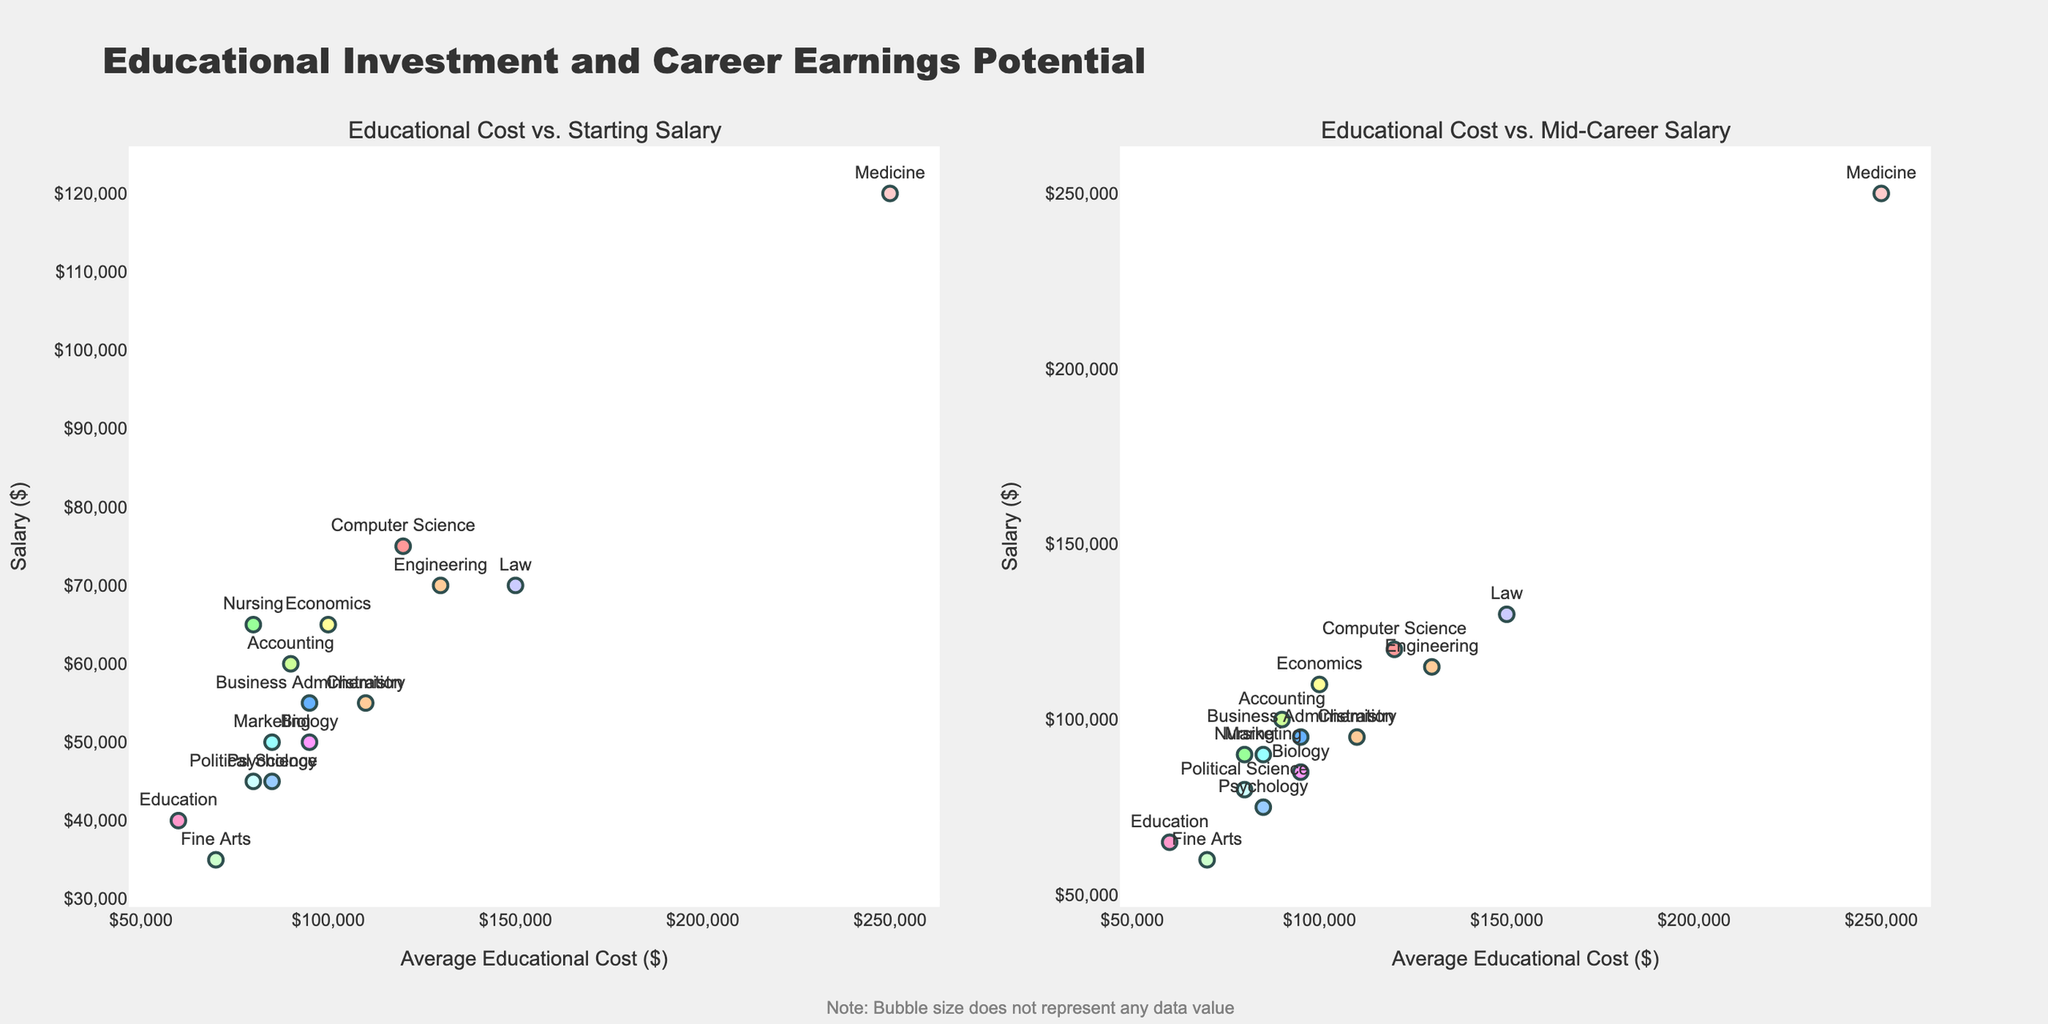How many intersections are represented in the figure? Count the number of unique intersections listed in the figure. Each intersection is represented as a data point with a label.
Answer: 10 Which intersection has the highest average wait time? Look at the y-axis in the first subplot and identify the data point with the highest value. The label for this data point indicates the intersection.
Answer: Downtown Square & City Hall Pl Which intersection has the lowest traffic flow? Refer to the x-axis in the second subplot and identify the data point with the smallest value. The label for this data point indicates the intersection.
Answer: Lakeview Dr & Harbor St Is there an intersection where both wait time and traffic flow are high? If so, which one? Observe both subplots and look for an intersection with high values on both the x and y axes. Intersection where both x and y values are high in any subplot signifies high wait time and high traffic flow.
Answer: Downtown Square & City Hall Pl What is the average wait time for intersections with a traffic flow of over 1000 vehicles per hour? Identify intersections with traffic flow >1000 vehicles per hour from either subplot. Then sum their wait times and divide by the number of such intersections. Intersections: Main St & Broadway, Oak Ln & River Dr, Washington Blvd & Jefferson Ave, Industrial Rd & Commerce Dr, Downtown Square & City Hall Pl. (45 + 60 + 50 + 55 + 65) / 5 = 55.
Answer: 55 seconds Which intersection has a lower wait time: Main St & Broadway or 5th Ave & Park Rd? Compare the average wait times from the first subplot for these two intersections. 5th Ave & Park Rd has a lower wait time than Main St & Broadway.
Answer: 5th Ave & Park Rd Are there any intersections where the average wait time is less than 30 seconds? Look at the y-values (wait times) in the first subplot and find any data points below 30 seconds.
Answer: Yes, Elm St & University Way and Lakeview Dr & Harbor St Which intersection shows the most balanced wait time and traffic flow? Look for an intersection whose data point in both subplots is neither too high nor too low but relatively centered in the distribution.
Answer: Central Pkwy & Market St What is the difference in traffic flow between Highland Ave & Sunset Blvd and Oak Ln & River Dr? Find the traffic flow values for both intersections from either subplot and calculate the difference. 1500 (Oak Ln & River Dr) - 1050 (Highland Ave & Sunset Blvd) = 450.
Answer: 450 vehicles per hour 